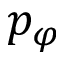Convert formula to latex. <formula><loc_0><loc_0><loc_500><loc_500>p _ { \varphi }</formula> 